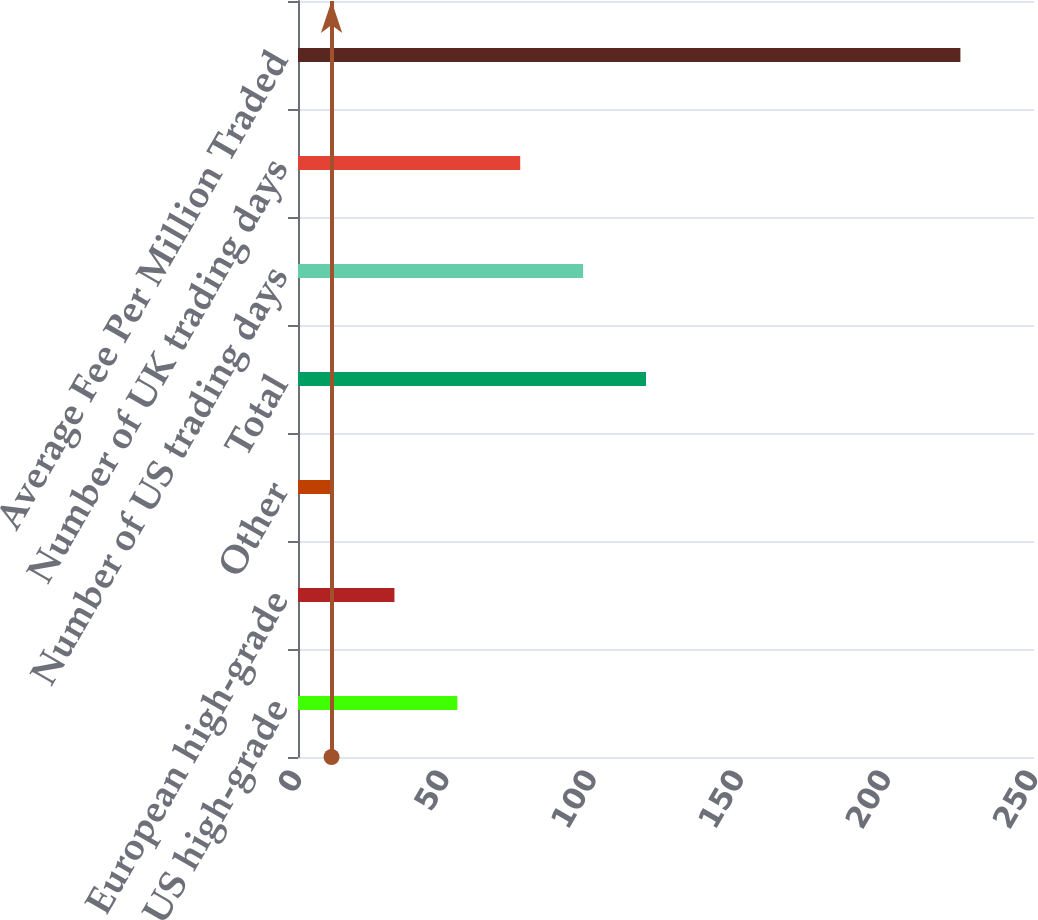Convert chart to OTSL. <chart><loc_0><loc_0><loc_500><loc_500><bar_chart><fcel>US high-grade<fcel>European high-grade<fcel>Other<fcel>Total<fcel>Number of US trading days<fcel>Number of UK trading days<fcel>Average Fee Per Million Traded<nl><fcel>54.12<fcel>32.76<fcel>11.4<fcel>118.2<fcel>96.84<fcel>75.48<fcel>225<nl></chart> 